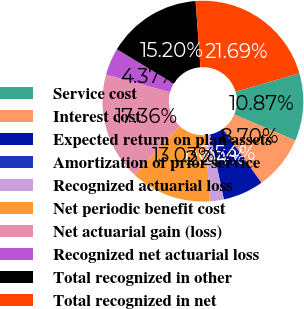<chart> <loc_0><loc_0><loc_500><loc_500><pie_chart><fcel>Service cost<fcel>Interest cost<fcel>Expected return on plan assets<fcel>Amortization of prior service<fcel>Recognized actuarial loss<fcel>Net periodic benefit cost<fcel>Net actuarial gain (loss)<fcel>Recognized net actuarial loss<fcel>Total recognized in other<fcel>Total recognized in net<nl><fcel>10.87%<fcel>8.7%<fcel>6.54%<fcel>0.04%<fcel>2.21%<fcel>13.03%<fcel>17.36%<fcel>4.37%<fcel>15.2%<fcel>21.69%<nl></chart> 